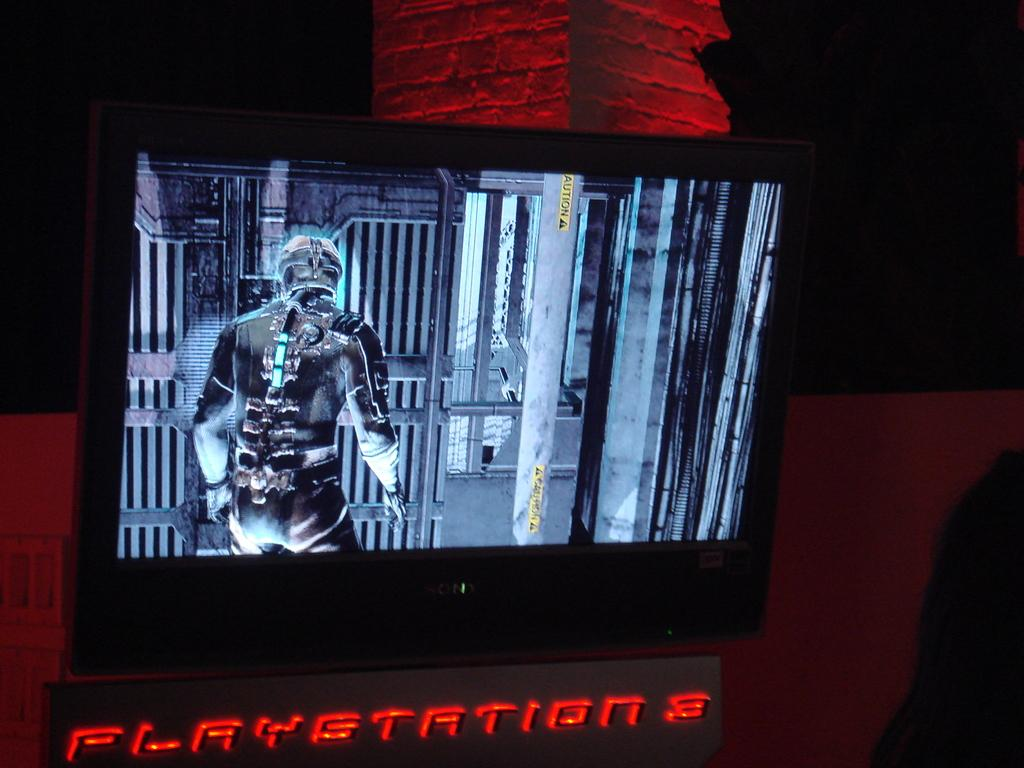Provide a one-sentence caption for the provided image. A Playstation 3 is set up below a television screen that is displaying a game on it. 